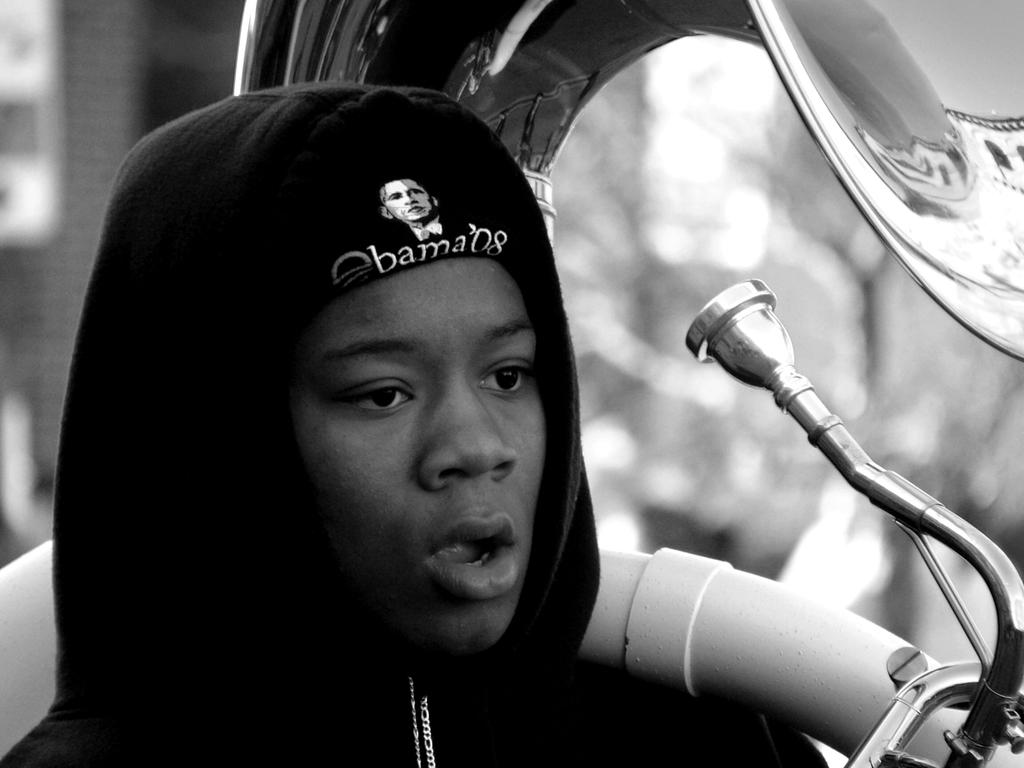Where was the image taken? The image is taken outdoors. What can be observed about the background of the image? The background of the image is blurred. Who is the main subject in the image? There is a boy in the middle of the image. What is the boy holding in his hand? The boy is holding a musical instrument in his hand. Can you see any docks in the image? There are no docks present in the image. Is there a faucet visible in the image? There is no faucet present in the image. 